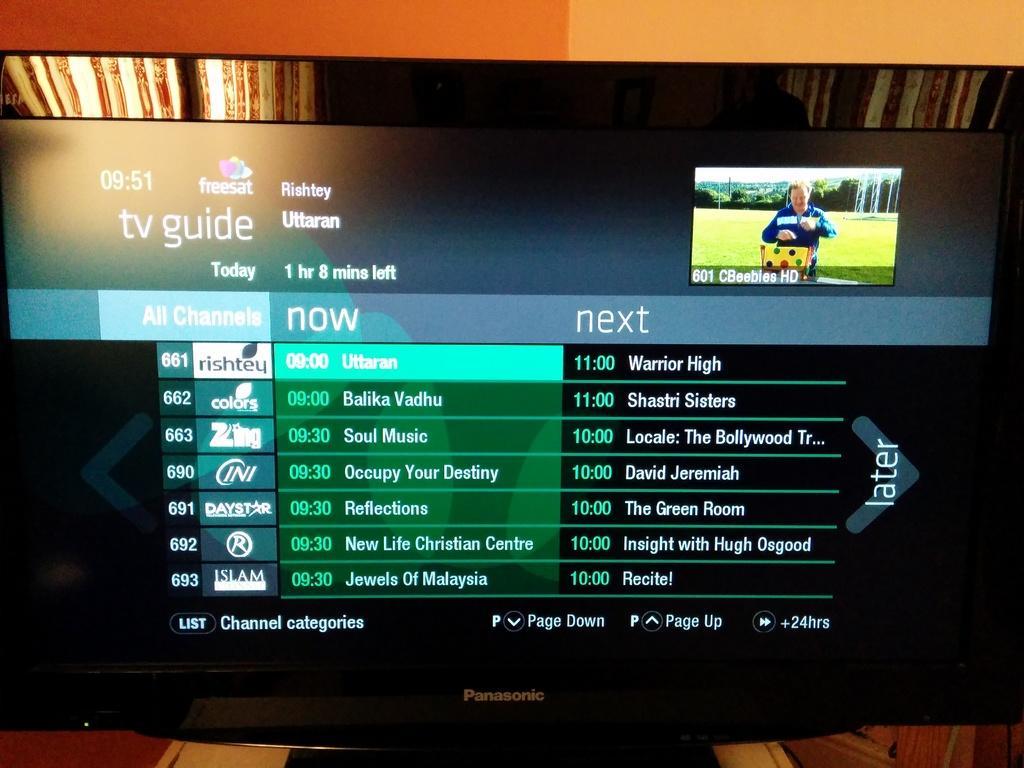Describe this image in one or two sentences. In this image I can see a television which is black in color and on the screen I can see a picture of a person wearing blue colored dress. Behind the television I can see the cream and orange colored wall. 